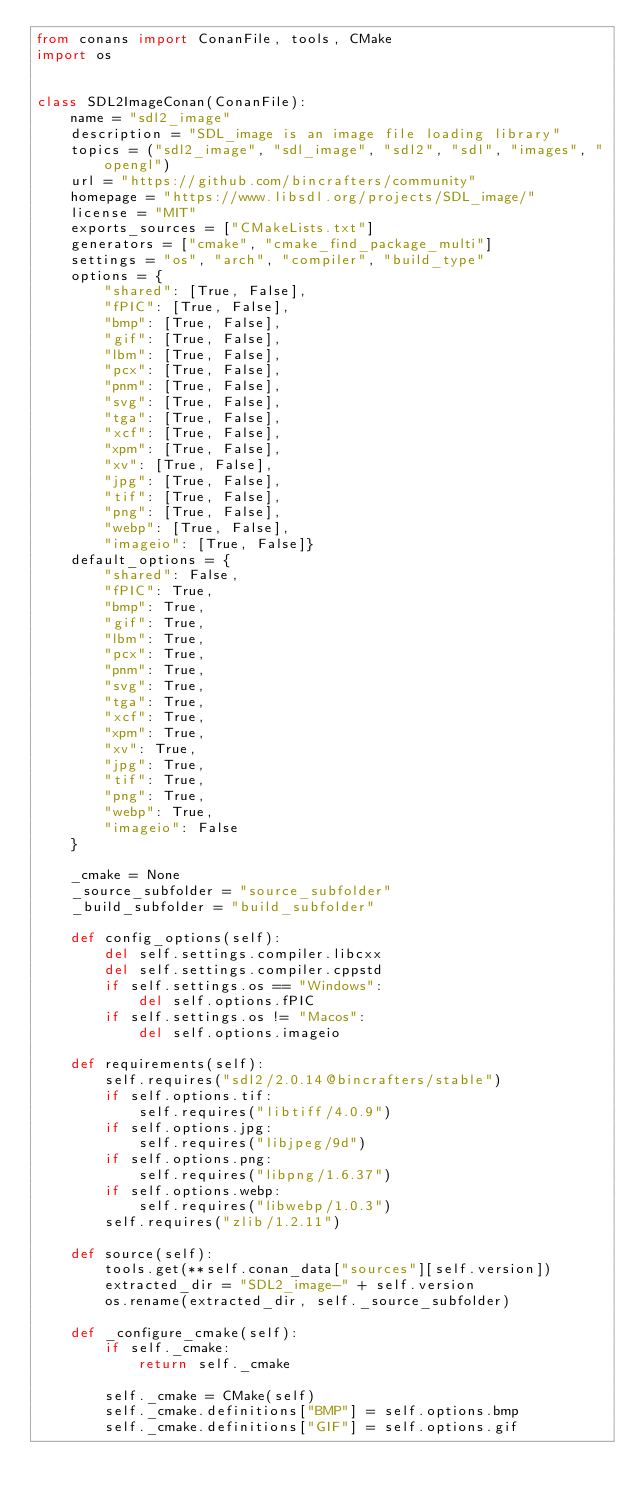Convert code to text. <code><loc_0><loc_0><loc_500><loc_500><_Python_>from conans import ConanFile, tools, CMake
import os


class SDL2ImageConan(ConanFile):
    name = "sdl2_image"
    description = "SDL_image is an image file loading library"
    topics = ("sdl2_image", "sdl_image", "sdl2", "sdl", "images", "opengl")
    url = "https://github.com/bincrafters/community"
    homepage = "https://www.libsdl.org/projects/SDL_image/"
    license = "MIT"
    exports_sources = ["CMakeLists.txt"]
    generators = ["cmake", "cmake_find_package_multi"]
    settings = "os", "arch", "compiler", "build_type"
    options = {
        "shared": [True, False],
        "fPIC": [True, False],
        "bmp": [True, False],
        "gif": [True, False],
        "lbm": [True, False],
        "pcx": [True, False],
        "pnm": [True, False],
        "svg": [True, False],
        "tga": [True, False],
        "xcf": [True, False],
        "xpm": [True, False],
        "xv": [True, False],
        "jpg": [True, False],
        "tif": [True, False],
        "png": [True, False],
        "webp": [True, False],
        "imageio": [True, False]}
    default_options = {
        "shared": False,
        "fPIC": True,
        "bmp": True,
        "gif": True,
        "lbm": True,
        "pcx": True,
        "pnm": True,
        "svg": True,
        "tga": True,
        "xcf": True,
        "xpm": True,
        "xv": True,
        "jpg": True,
        "tif": True,
        "png": True,
        "webp": True,
        "imageio": False
    }

    _cmake = None
    _source_subfolder = "source_subfolder"
    _build_subfolder = "build_subfolder"

    def config_options(self):
        del self.settings.compiler.libcxx
        del self.settings.compiler.cppstd
        if self.settings.os == "Windows":
            del self.options.fPIC
        if self.settings.os != "Macos":
            del self.options.imageio

    def requirements(self):
        self.requires("sdl2/2.0.14@bincrafters/stable")
        if self.options.tif:
            self.requires("libtiff/4.0.9")
        if self.options.jpg:
            self.requires("libjpeg/9d")
        if self.options.png:
            self.requires("libpng/1.6.37")
        if self.options.webp:
            self.requires("libwebp/1.0.3")
        self.requires("zlib/1.2.11")

    def source(self):
        tools.get(**self.conan_data["sources"][self.version])
        extracted_dir = "SDL2_image-" + self.version
        os.rename(extracted_dir, self._source_subfolder)

    def _configure_cmake(self):
        if self._cmake:
            return self._cmake

        self._cmake = CMake(self)
        self._cmake.definitions["BMP"] = self.options.bmp
        self._cmake.definitions["GIF"] = self.options.gif</code> 